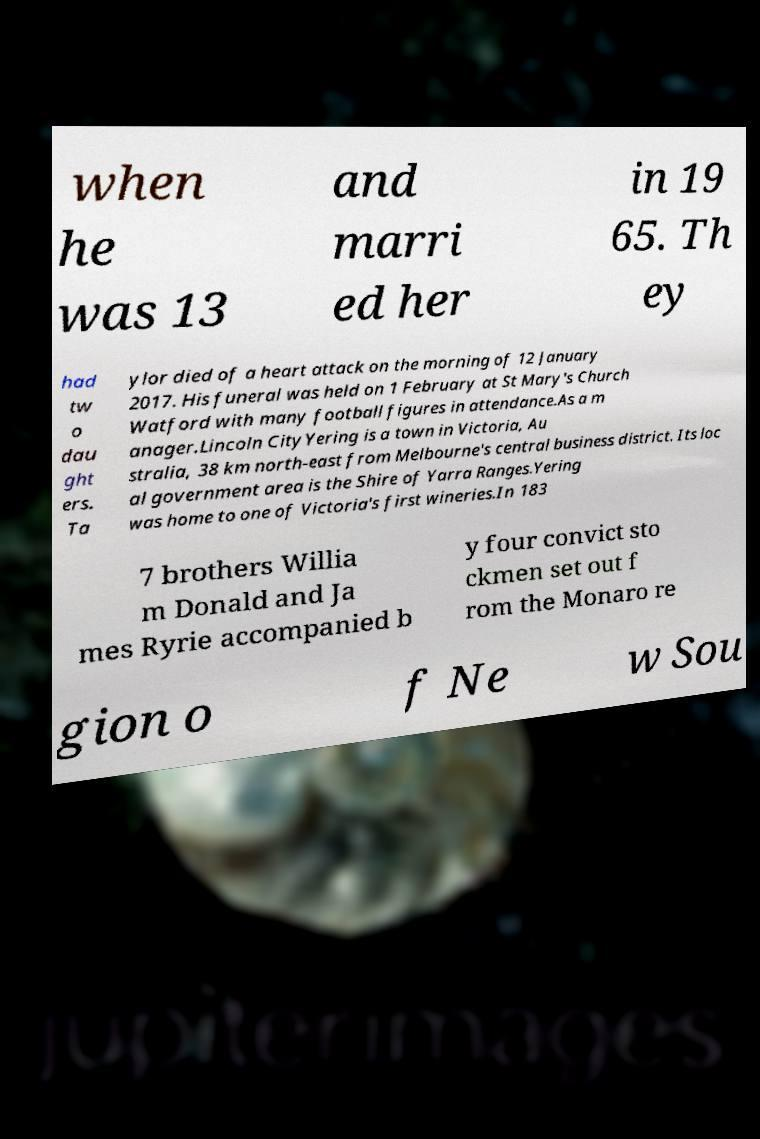Can you accurately transcribe the text from the provided image for me? when he was 13 and marri ed her in 19 65. Th ey had tw o dau ght ers. Ta ylor died of a heart attack on the morning of 12 January 2017. His funeral was held on 1 February at St Mary's Church Watford with many football figures in attendance.As a m anager.Lincoln CityYering is a town in Victoria, Au stralia, 38 km north-east from Melbourne's central business district. Its loc al government area is the Shire of Yarra Ranges.Yering was home to one of Victoria's first wineries.In 183 7 brothers Willia m Donald and Ja mes Ryrie accompanied b y four convict sto ckmen set out f rom the Monaro re gion o f Ne w Sou 